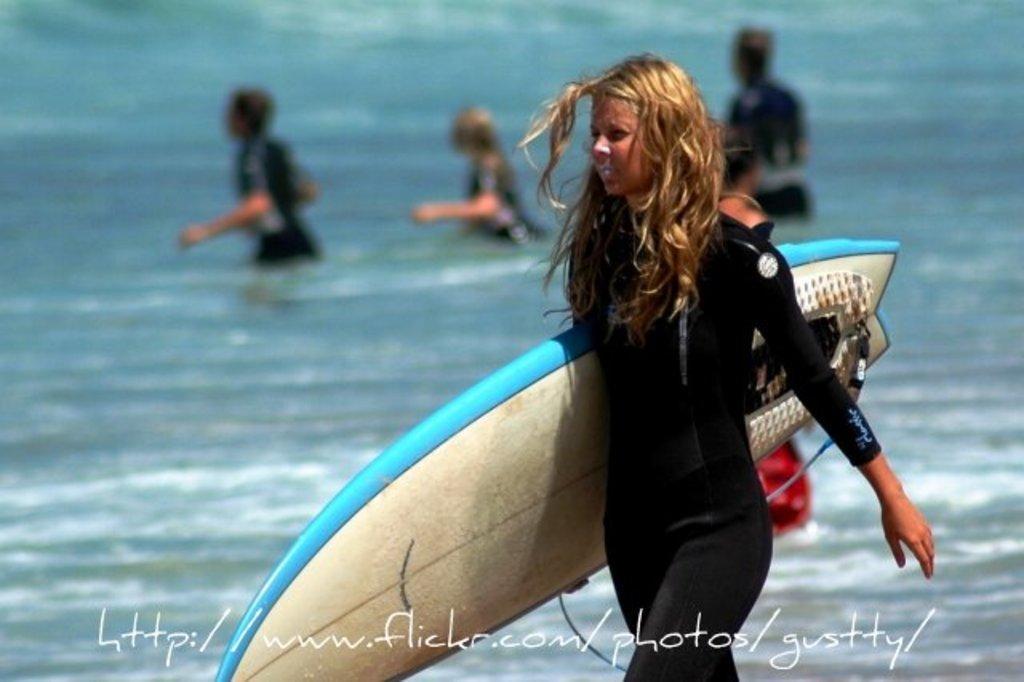In one or two sentences, can you explain what this image depicts? In this image I can see a woman who is walking by holding a skateboard in a her hand wearing a suit. In the background I can also see water with three people in it. 